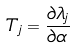<formula> <loc_0><loc_0><loc_500><loc_500>T _ { j } = \frac { \partial \lambda _ { j } } { \partial \alpha }</formula> 